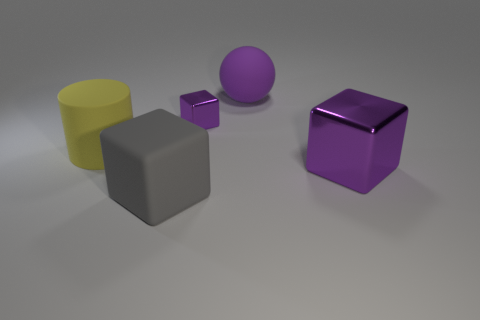Is the number of big rubber cylinders that are behind the matte sphere the same as the number of gray rubber balls?
Ensure brevity in your answer.  Yes. What number of cylinders are either large gray rubber objects or tiny things?
Give a very brief answer. 0. Is the color of the rubber cylinder the same as the small metallic object?
Ensure brevity in your answer.  No. Are there the same number of large balls behind the small object and large gray rubber objects on the left side of the gray object?
Offer a terse response. No. The rubber ball is what color?
Offer a very short reply. Purple. What number of things are cubes that are behind the big gray matte block or purple balls?
Offer a very short reply. 3. There is a thing that is in front of the large purple cube; does it have the same size as the purple shiny block behind the big yellow thing?
Keep it short and to the point. No. Is there anything else that is made of the same material as the gray cube?
Offer a very short reply. Yes. What number of objects are blocks behind the big gray matte object or large purple objects that are behind the small cube?
Provide a succinct answer. 3. Is the large gray cube made of the same material as the big block on the right side of the large gray matte thing?
Your answer should be very brief. No. 